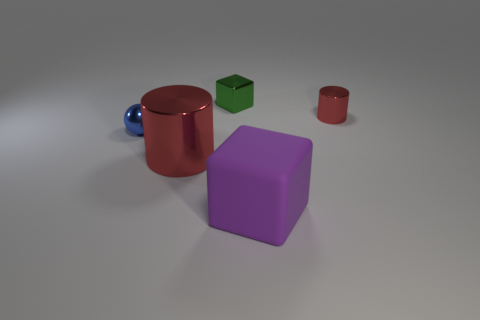Is the metal sphere the same size as the matte cube?
Your response must be concise. No. What number of metal cylinders are to the right of the large object that is left of the green thing?
Your response must be concise. 1. What is the material of the small green object that is the same shape as the big matte thing?
Make the answer very short. Metal. The big cube has what color?
Offer a terse response. Purple. How many things are tiny green metallic things or small red things?
Keep it short and to the point. 2. What shape is the red metallic thing behind the metallic thing that is in front of the small blue metal sphere?
Provide a short and direct response. Cylinder. What number of other objects are there of the same material as the tiny cylinder?
Give a very brief answer. 3. Is the material of the large red cylinder the same as the object that is right of the purple thing?
Keep it short and to the point. Yes. How many things are either objects that are in front of the shiny cube or tiny things that are right of the large rubber block?
Your response must be concise. 4. What number of other objects are there of the same color as the small shiny block?
Provide a short and direct response. 0. 